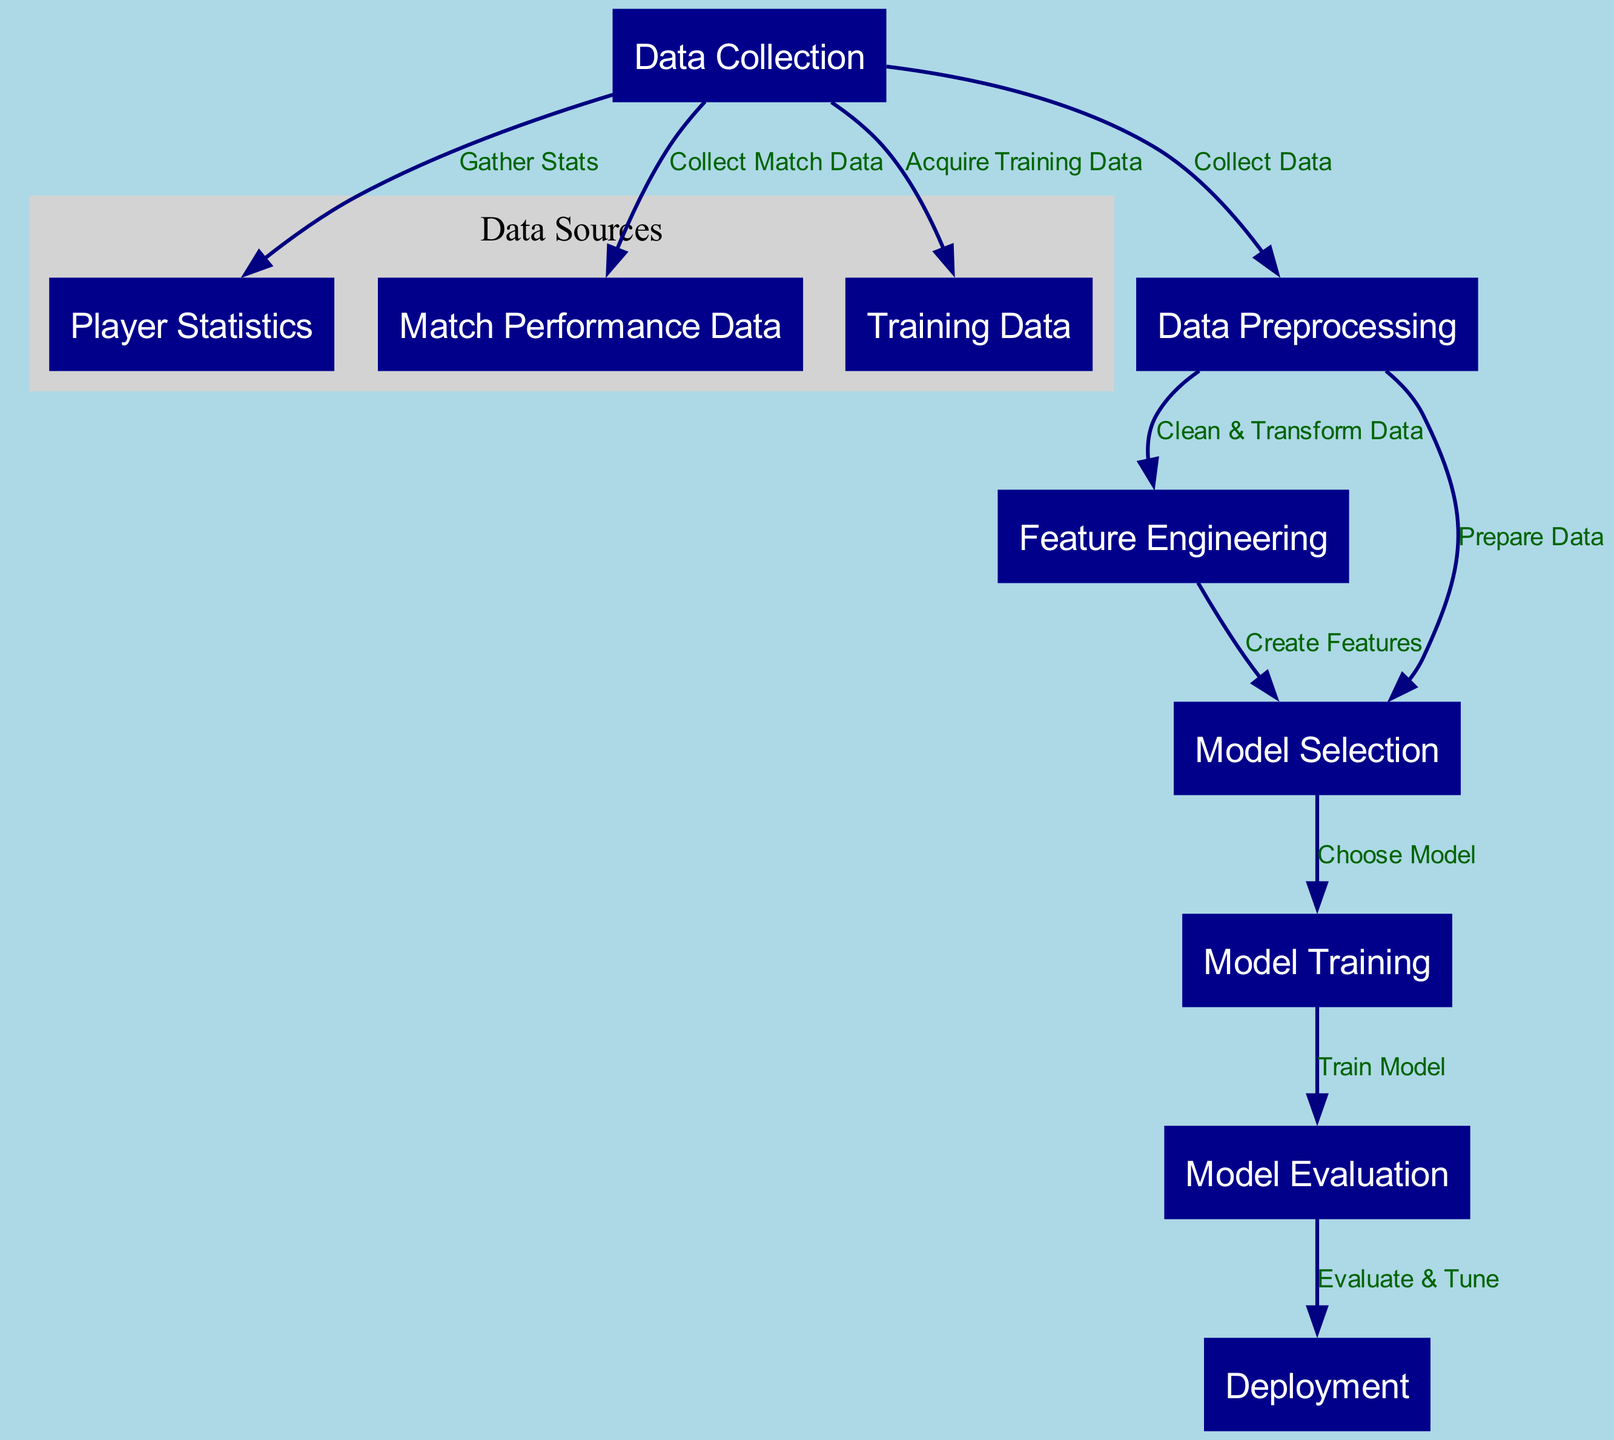What is the total number of nodes in the diagram? The diagram has a total of 10 nodes listed, including data collection, player statistics, match performance data, training data, data preprocessing, feature engineering, model selection, model training, model evaluation, and deployment.
Answer: 10 Which node represents the data transformation process? The edge from the data preprocessing node to the feature engineering node indicates that the process of cleaning and transforming the data occurs here.
Answer: Data Preprocessing What is the connection between data collection and player statistics? The data collection node has a directed edge to the player statistics node, labeled "Gather Stats," indicating that player statistics are retrieved from data collection.
Answer: Gather Stats From which node does model evaluation follow? The model evaluation node has a direct incoming edge from the model training node, showing that model evaluation occurs after model training is completed.
Answer: Model Training What process comes immediately after data preprocessing in the diagram? After data preprocessing, the next step is feature engineering, which is indicated by the edge labeled "Clean & Transform Data" connecting the two nodes.
Answer: Feature Engineering Which node is responsible for preparing data for model selection? The diagram shows that data preprocessing is responsible for preparing data for model selection as indicated by the edge labeled "Prepare Data."
Answer: Data Preprocessing What is the final step in the diagram? The last node, deployment, is the final step indicated by the edge coming from model evaluation, which highlights that this is where the results are put into use.
Answer: Deployment In total, how many edges are present in the diagram? Counting the connections between the nodes, there are 9 directed edges showing the flow of the process from data collection to deployment.
Answer: 9 Which node follows feature engineering during the model building process? Feature engineering directs to the model selection node as its next step, indicating that after creating features, model selection takes place.
Answer: Model Selection What type of data is collected from matches? The node labeled match performance data specifies that this type of data is collected during the initial data collection phase.
Answer: Match Performance Data 